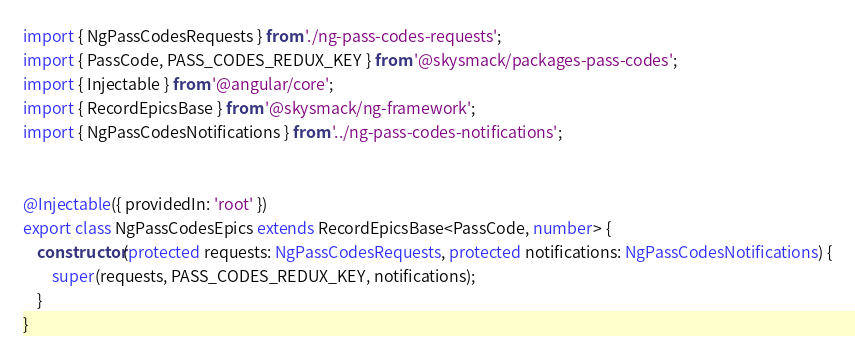<code> <loc_0><loc_0><loc_500><loc_500><_TypeScript_>import { NgPassCodesRequests } from './ng-pass-codes-requests';
import { PassCode, PASS_CODES_REDUX_KEY } from '@skysmack/packages-pass-codes';
import { Injectable } from '@angular/core';
import { RecordEpicsBase } from '@skysmack/ng-framework';
import { NgPassCodesNotifications } from '../ng-pass-codes-notifications';


@Injectable({ providedIn: 'root' })
export class NgPassCodesEpics extends RecordEpicsBase<PassCode, number> {
    constructor(protected requests: NgPassCodesRequests, protected notifications: NgPassCodesNotifications) {
        super(requests, PASS_CODES_REDUX_KEY, notifications);
    }
}
</code> 